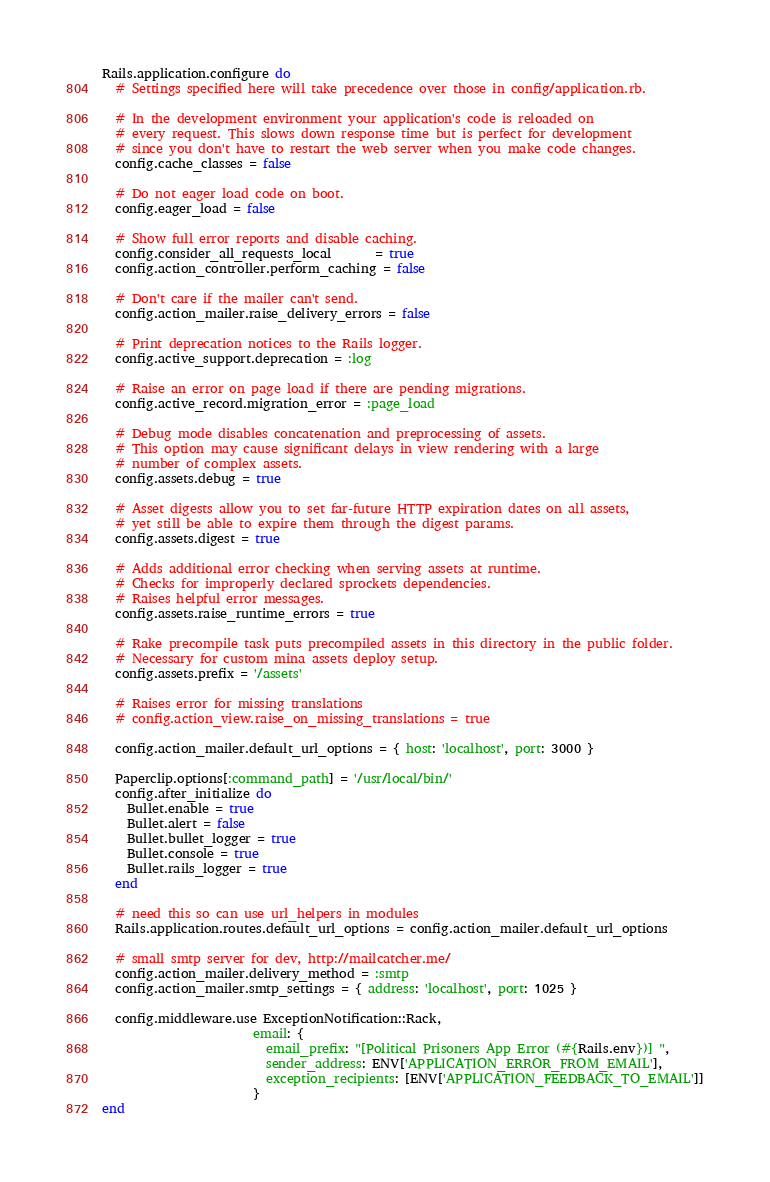<code> <loc_0><loc_0><loc_500><loc_500><_Ruby_>Rails.application.configure do
  # Settings specified here will take precedence over those in config/application.rb.

  # In the development environment your application's code is reloaded on
  # every request. This slows down response time but is perfect for development
  # since you don't have to restart the web server when you make code changes.
  config.cache_classes = false

  # Do not eager load code on boot.
  config.eager_load = false

  # Show full error reports and disable caching.
  config.consider_all_requests_local       = true
  config.action_controller.perform_caching = false

  # Don't care if the mailer can't send.
  config.action_mailer.raise_delivery_errors = false

  # Print deprecation notices to the Rails logger.
  config.active_support.deprecation = :log

  # Raise an error on page load if there are pending migrations.
  config.active_record.migration_error = :page_load

  # Debug mode disables concatenation and preprocessing of assets.
  # This option may cause significant delays in view rendering with a large
  # number of complex assets.
  config.assets.debug = true

  # Asset digests allow you to set far-future HTTP expiration dates on all assets,
  # yet still be able to expire them through the digest params.
  config.assets.digest = true

  # Adds additional error checking when serving assets at runtime.
  # Checks for improperly declared sprockets dependencies.
  # Raises helpful error messages.
  config.assets.raise_runtime_errors = true

  # Rake precompile task puts precompiled assets in this directory in the public folder.
  # Necessary for custom mina assets deploy setup.
  config.assets.prefix = '/assets'

  # Raises error for missing translations
  # config.action_view.raise_on_missing_translations = true

  config.action_mailer.default_url_options = { host: 'localhost', port: 3000 }

  Paperclip.options[:command_path] = '/usr/local/bin/'
  config.after_initialize do
    Bullet.enable = true
    Bullet.alert = false
    Bullet.bullet_logger = true
    Bullet.console = true
    Bullet.rails_logger = true
  end

  # need this so can use url_helpers in modules
  Rails.application.routes.default_url_options = config.action_mailer.default_url_options

  # small smtp server for dev, http://mailcatcher.me/
  config.action_mailer.delivery_method = :smtp
  config.action_mailer.smtp_settings = { address: 'localhost', port: 1025 }

  config.middleware.use ExceptionNotification::Rack,
                        email: {
                          email_prefix: "[Political Prisoners App Error (#{Rails.env})] ",
                          sender_address: ENV['APPLICATION_ERROR_FROM_EMAIL'],
                          exception_recipients: [ENV['APPLICATION_FEEDBACK_TO_EMAIL']]
                        }
end
</code> 